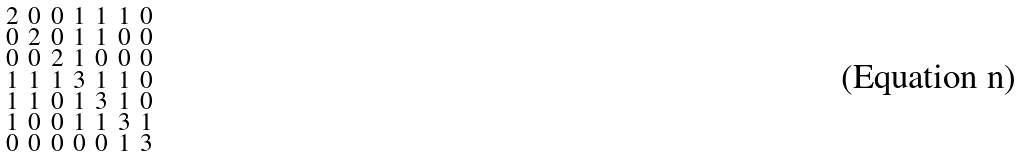<formula> <loc_0><loc_0><loc_500><loc_500>\begin{smallmatrix} 2 & 0 & 0 & 1 & 1 & 1 & 0 \\ 0 & 2 & 0 & 1 & 1 & 0 & 0 \\ 0 & 0 & 2 & 1 & 0 & 0 & 0 \\ 1 & 1 & 1 & 3 & 1 & 1 & 0 \\ 1 & 1 & 0 & 1 & 3 & 1 & 0 \\ 1 & 0 & 0 & 1 & 1 & 3 & 1 \\ 0 & 0 & 0 & 0 & 0 & 1 & 3 \end{smallmatrix}</formula> 